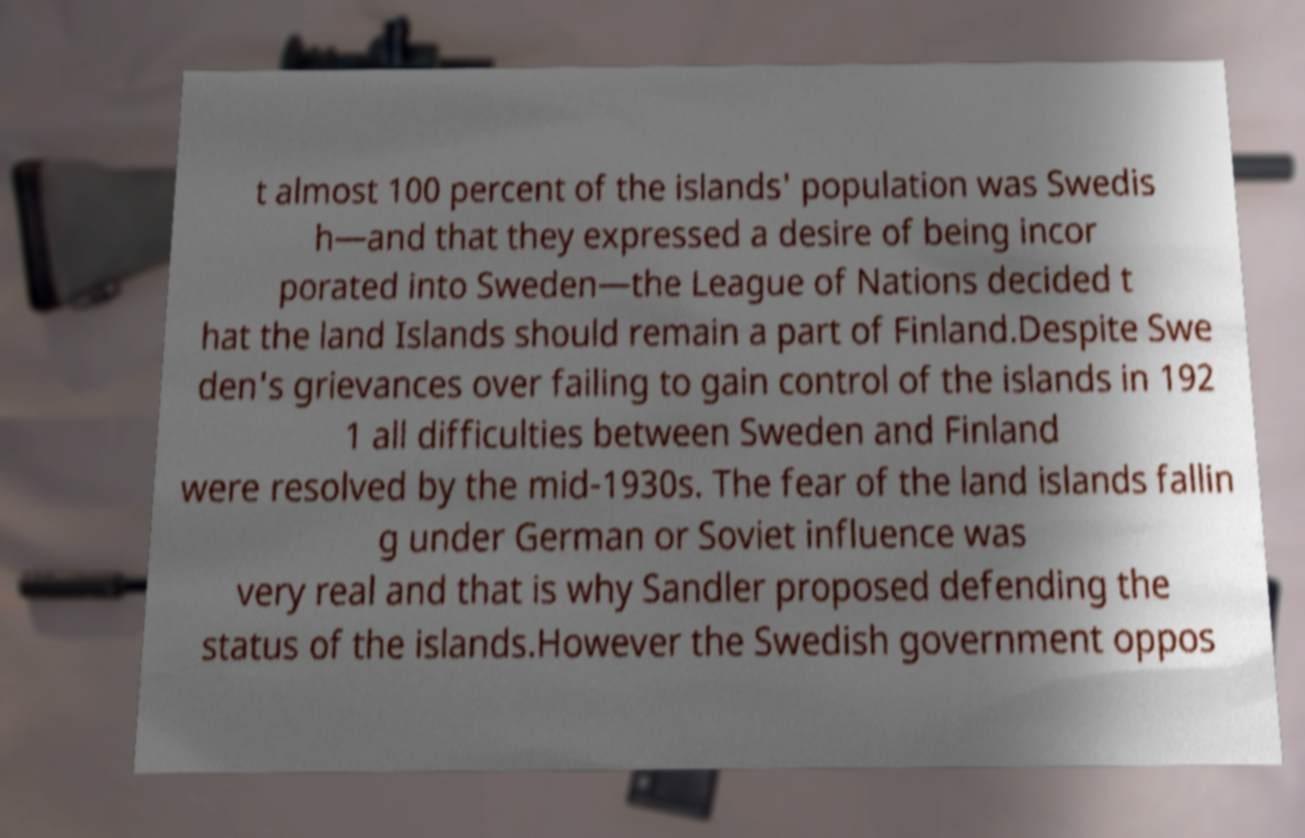Please read and relay the text visible in this image. What does it say? t almost 100 percent of the islands' population was Swedis h—and that they expressed a desire of being incor porated into Sweden—the League of Nations decided t hat the land Islands should remain a part of Finland.Despite Swe den's grievances over failing to gain control of the islands in 192 1 all difficulties between Sweden and Finland were resolved by the mid-1930s. The fear of the land islands fallin g under German or Soviet influence was very real and that is why Sandler proposed defending the status of the islands.However the Swedish government oppos 